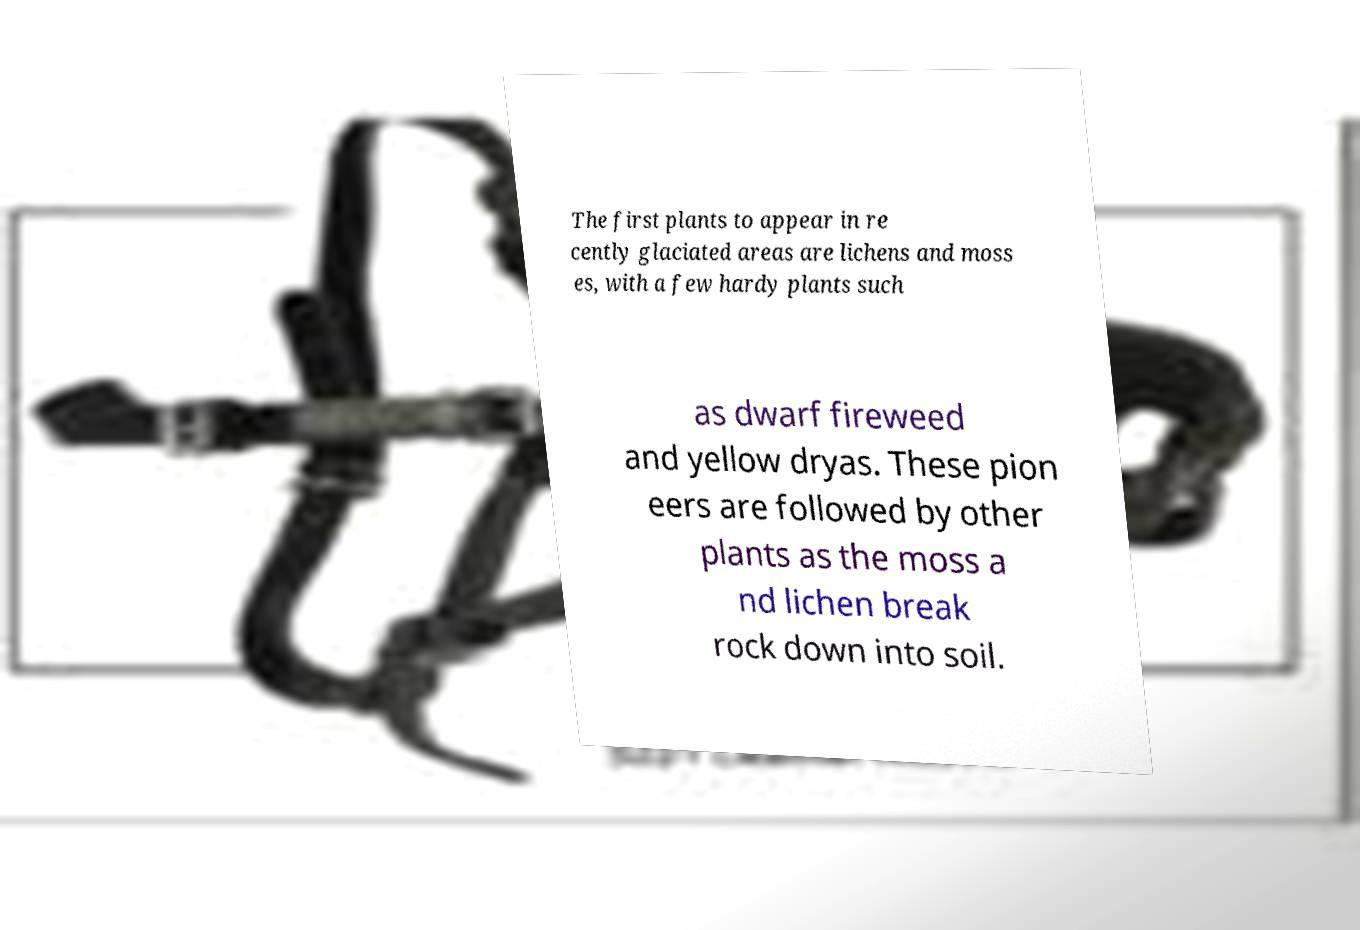Can you accurately transcribe the text from the provided image for me? The first plants to appear in re cently glaciated areas are lichens and moss es, with a few hardy plants such as dwarf fireweed and yellow dryas. These pion eers are followed by other plants as the moss a nd lichen break rock down into soil. 